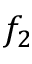<formula> <loc_0><loc_0><loc_500><loc_500>f _ { 2 }</formula> 